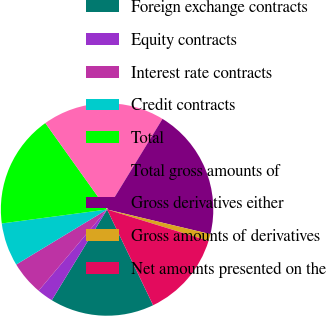<chart> <loc_0><loc_0><loc_500><loc_500><pie_chart><fcel>Foreign exchange contracts<fcel>Equity contracts<fcel>Interest rate contracts<fcel>Credit contracts<fcel>Total<fcel>Total gross amounts of<fcel>Gross derivatives either<fcel>Gross amounts of derivatives<fcel>Net amounts presented on the<nl><fcel>15.85%<fcel>2.43%<fcel>5.19%<fcel>6.57%<fcel>17.23%<fcel>18.61%<fcel>19.99%<fcel>1.05%<fcel>13.09%<nl></chart> 